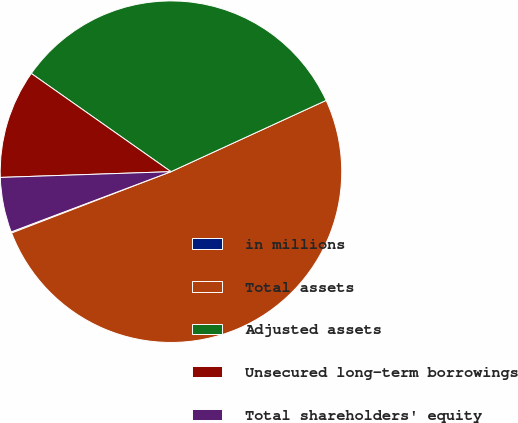<chart> <loc_0><loc_0><loc_500><loc_500><pie_chart><fcel>in millions<fcel>Total assets<fcel>Adjusted assets<fcel>Unsecured long-term borrowings<fcel>Total shareholders' equity<nl><fcel>0.11%<fcel>51.01%<fcel>33.39%<fcel>10.29%<fcel>5.2%<nl></chart> 